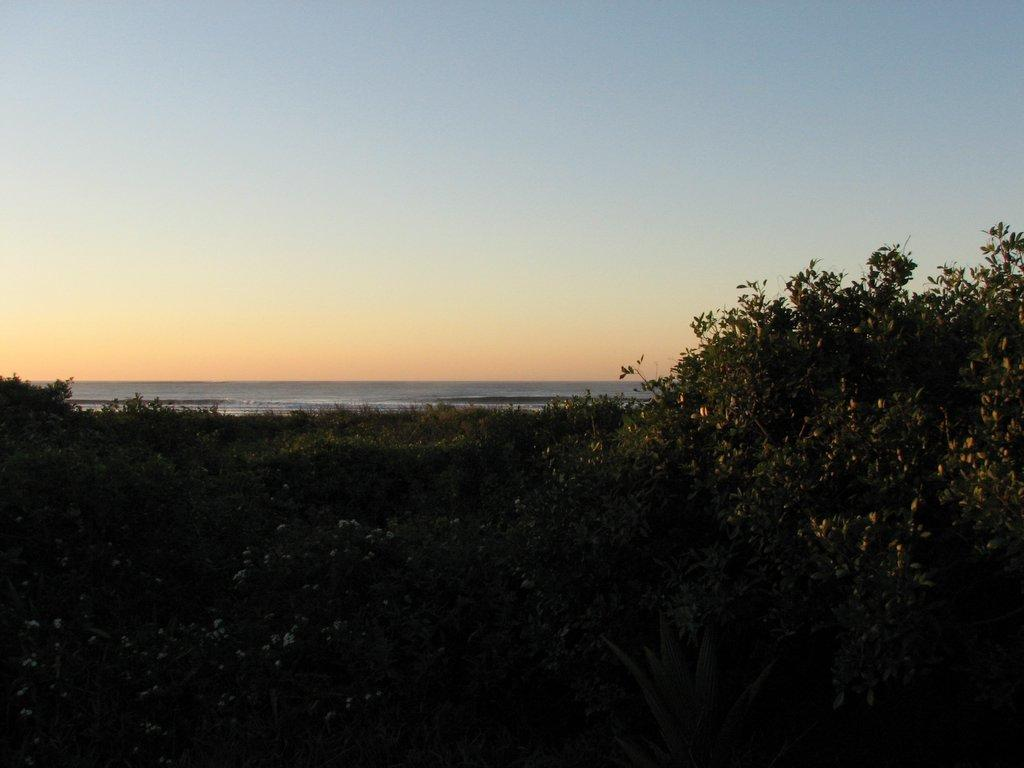What type of vegetation can be seen in the image? There are trees and plants in the image. What is visible at the bottom of the image? There is water visible at the bottom of the image. What is visible at the top of the image? The sky is visible at the top of the image. What type of quartz can be seen in the image? There is no quartz present in the image. Is there a notebook visible in the image? There is no notebook present in the image. 